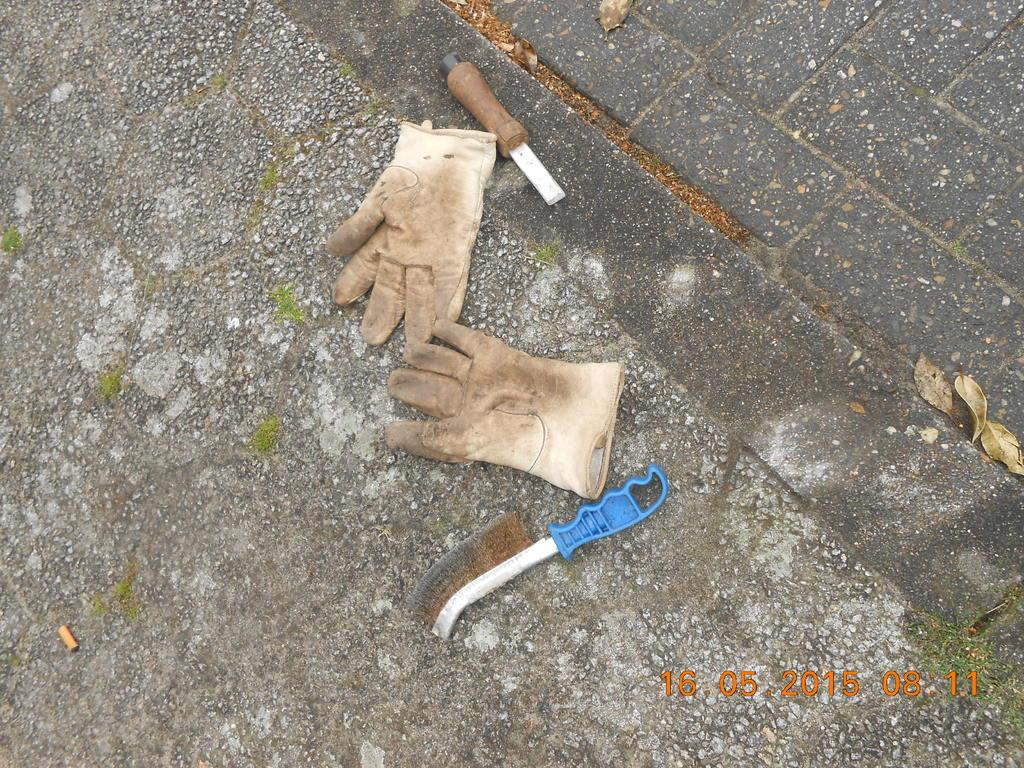What items can be seen on the road in the image? There are gloves, a brush, and a tool on the road. Can you describe the gloves in the image? The gloves are on the road. What else is present on the road besides the gloves? There is a brush and a tool on the road. What country is the sneeze originating from in the image? There is no sneeze present in the image, so it is not possible to determine its origin. 